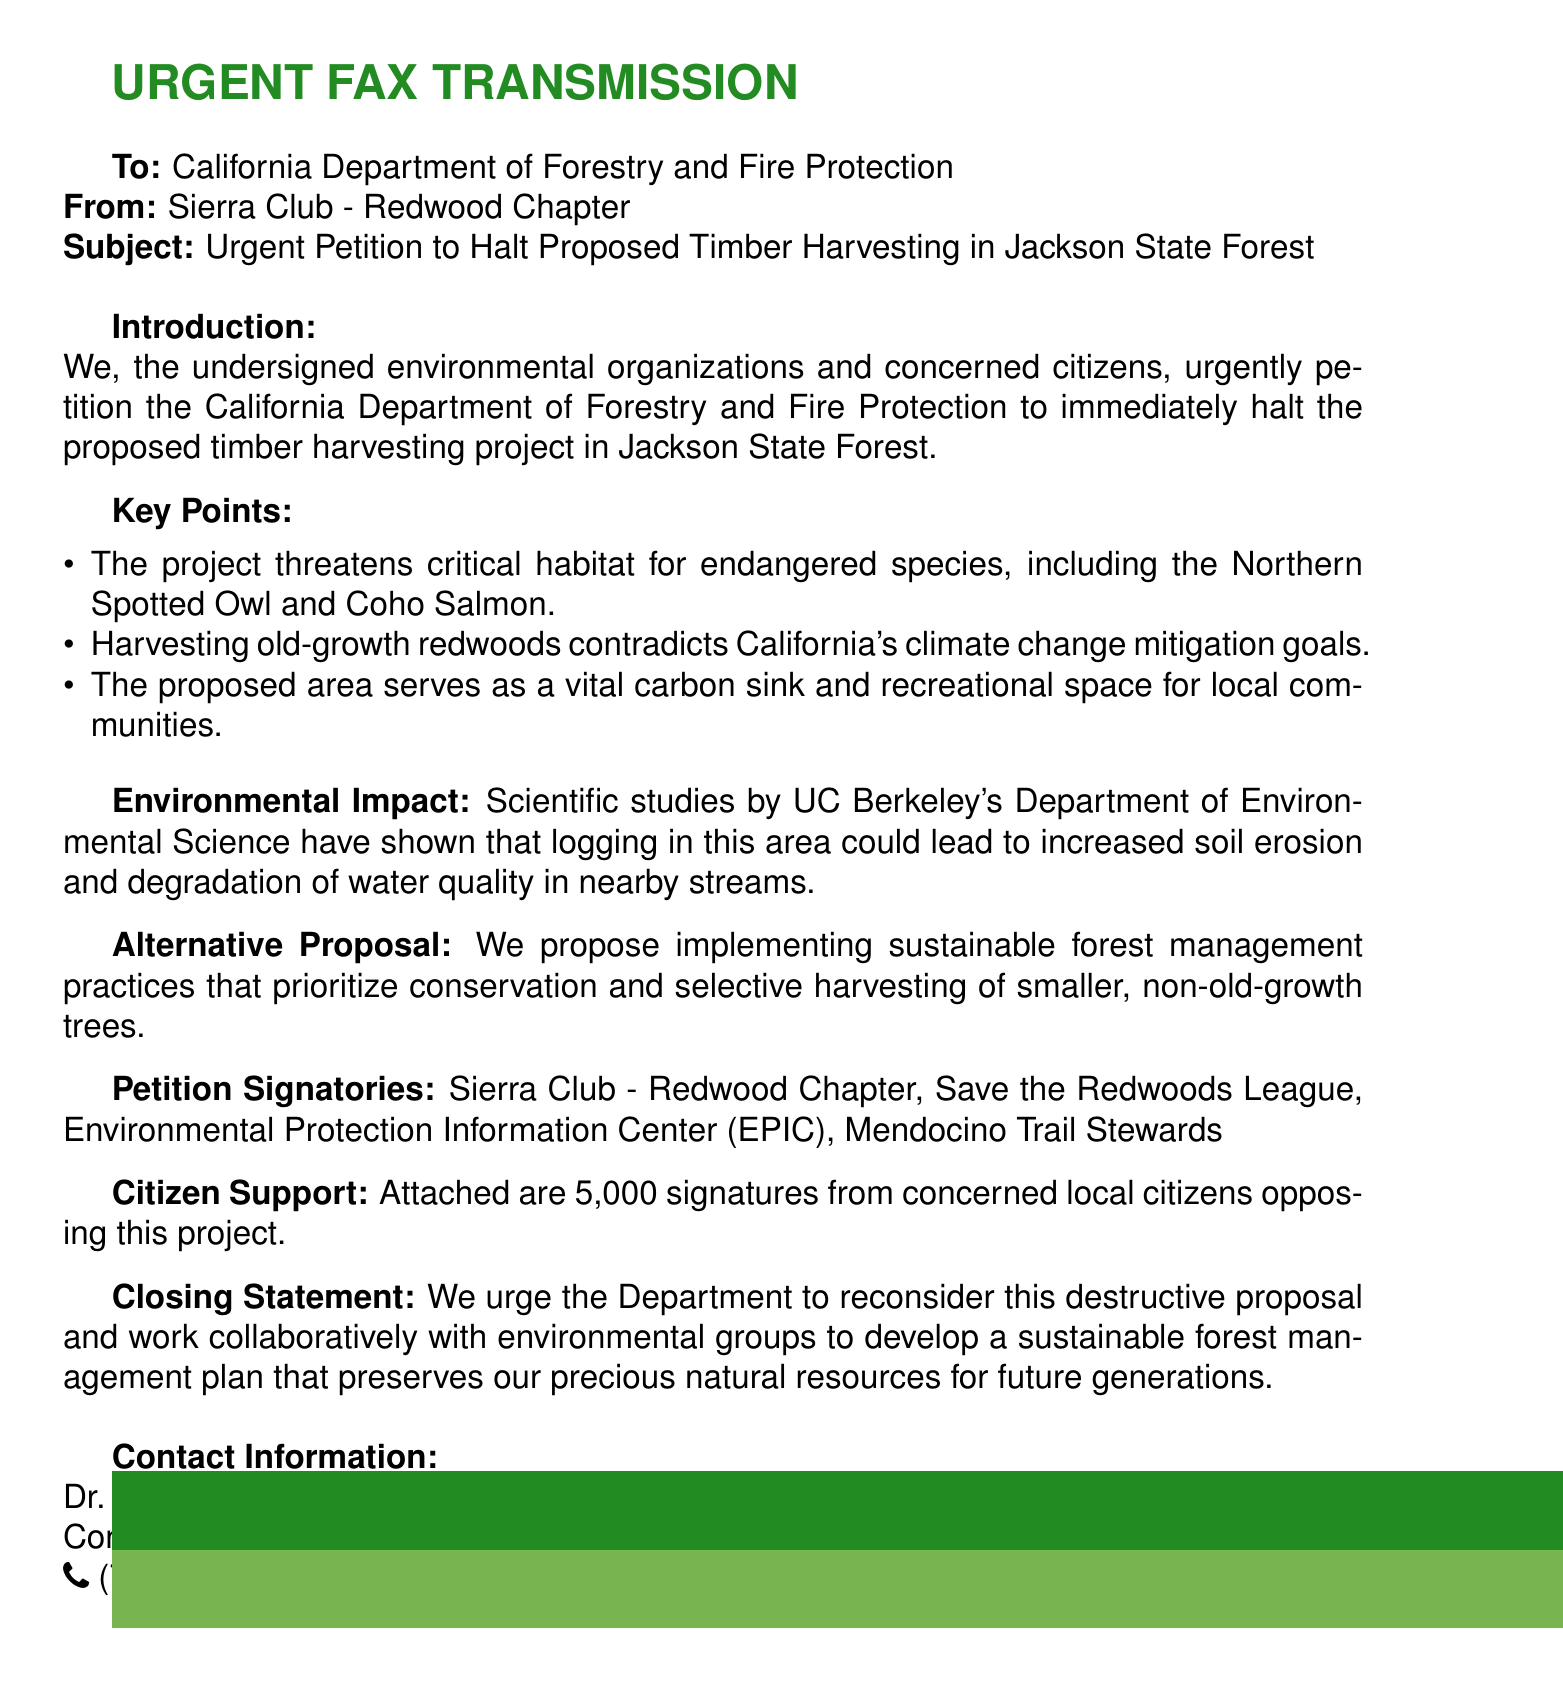What is the title of the fax? The title of the fax is presented at the top of the document, indicating the subject matter.
Answer: Urgent Petition to Halt Proposed Timber Harvesting in Jackson State Forest Who is the sender of the fax? The sender of the fax is identified at the beginning of the document.
Answer: Sierra Club - Redwood Chapter What is the total number of signatures attached? The document mentions the number of signatures supporting the petition against the timber harvesting project.
Answer: 5,000 Which species are mentioned as endangered in the petition? The endangered species cited in the document are specifically noted in the key points section.
Answer: Northern Spotted Owl and Coho Salmon What alternative proposal is suggested in the fax? The document outlines a proposal that serves as a counter to the timber harvesting plan.
Answer: Sustainable forest management practices What is the contact phone number provided? The fax lists the contact phone number for further inquiries regarding the petition.
Answer: (707) 555-1234 What is the main environmental concern addressed in the document? The fax discusses a significant environmental issue related to the timber harvesting project and its impact.
Answer: Increased soil erosion and degradation of water quality Who conducted the scientific studies referenced? The studies that provide evidence for the concerns raised in the fax are linked to a specific academic institution.
Answer: UC Berkeley's Department of Environmental Science 